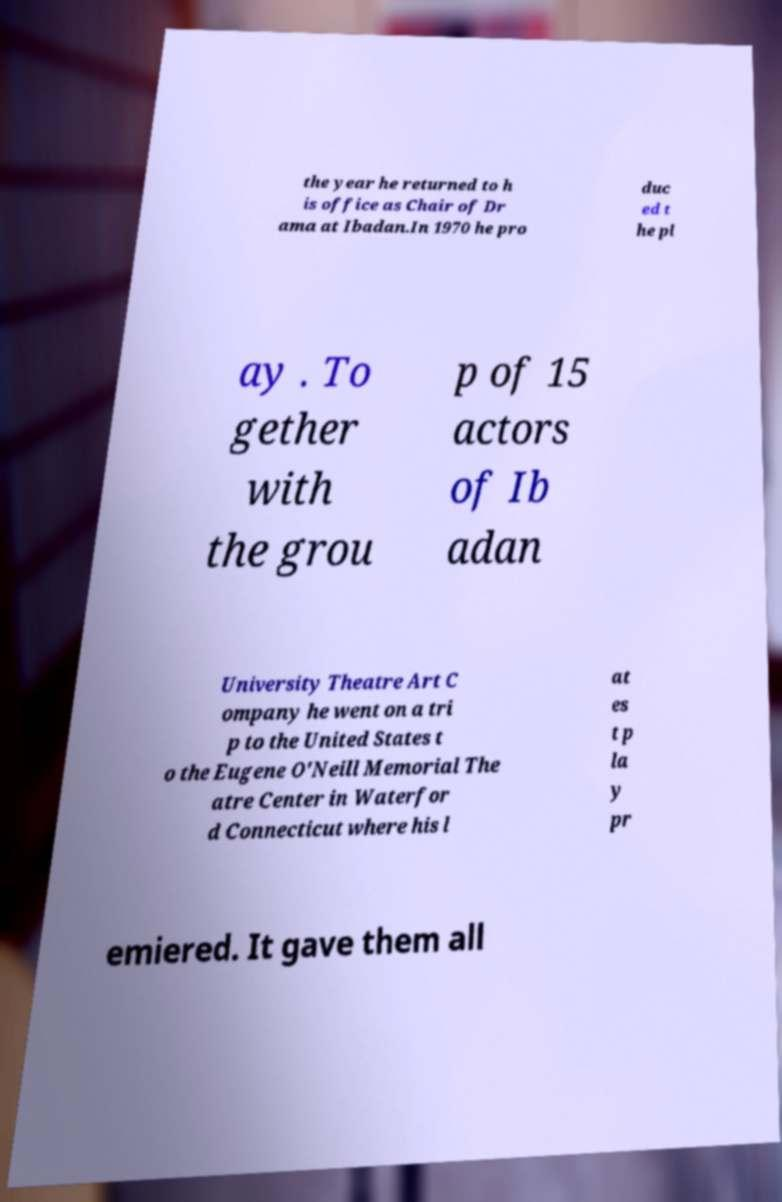Can you accurately transcribe the text from the provided image for me? the year he returned to h is office as Chair of Dr ama at Ibadan.In 1970 he pro duc ed t he pl ay . To gether with the grou p of 15 actors of Ib adan University Theatre Art C ompany he went on a tri p to the United States t o the Eugene O'Neill Memorial The atre Center in Waterfor d Connecticut where his l at es t p la y pr emiered. It gave them all 